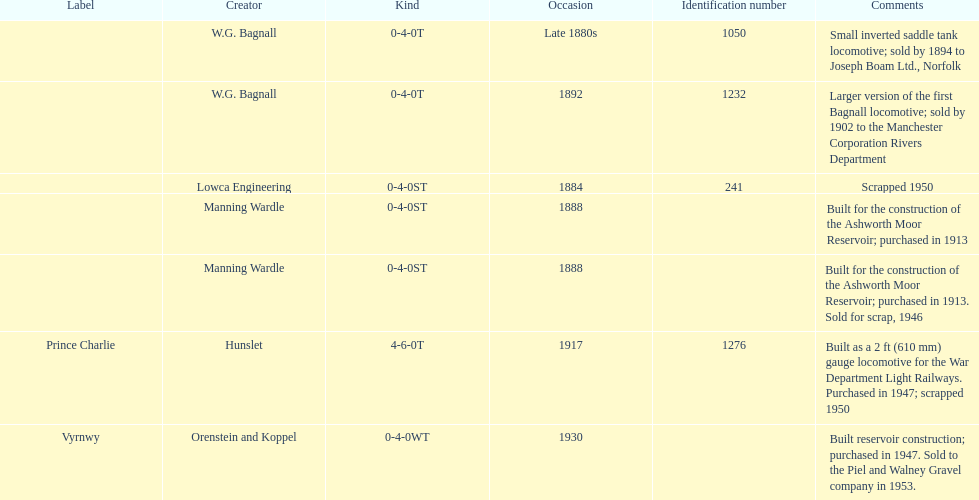How many locomotives were scrapped? 3. 